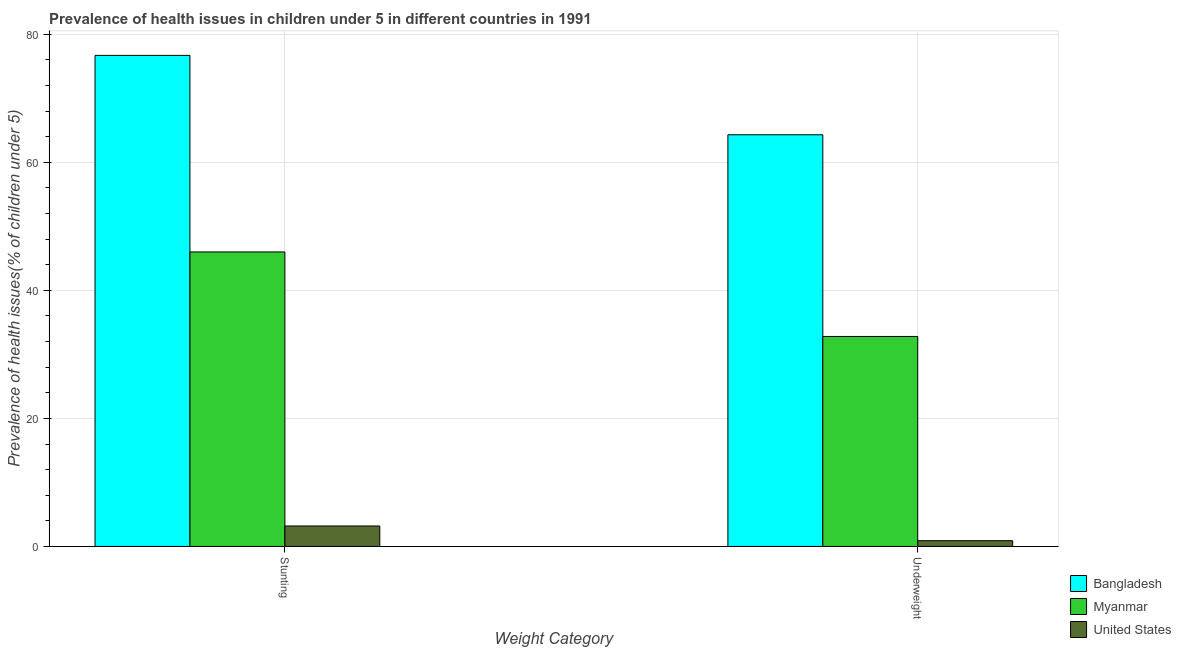How many different coloured bars are there?
Give a very brief answer. 3. How many groups of bars are there?
Ensure brevity in your answer.  2. Are the number of bars per tick equal to the number of legend labels?
Your answer should be very brief. Yes. How many bars are there on the 1st tick from the left?
Offer a terse response. 3. What is the label of the 2nd group of bars from the left?
Provide a succinct answer. Underweight. What is the percentage of underweight children in United States?
Give a very brief answer. 0.9. Across all countries, what is the maximum percentage of underweight children?
Provide a succinct answer. 64.3. Across all countries, what is the minimum percentage of stunted children?
Provide a succinct answer. 3.2. In which country was the percentage of stunted children maximum?
Provide a short and direct response. Bangladesh. What is the total percentage of underweight children in the graph?
Provide a succinct answer. 98. What is the difference between the percentage of stunted children in United States and that in Bangladesh?
Make the answer very short. -73.5. What is the difference between the percentage of stunted children in United States and the percentage of underweight children in Bangladesh?
Keep it short and to the point. -61.1. What is the average percentage of stunted children per country?
Give a very brief answer. 41.97. What is the difference between the percentage of stunted children and percentage of underweight children in Myanmar?
Make the answer very short. 13.2. What is the ratio of the percentage of stunted children in Bangladesh to that in Myanmar?
Offer a terse response. 1.67. Is the percentage of underweight children in Bangladesh less than that in Myanmar?
Provide a succinct answer. No. In how many countries, is the percentage of stunted children greater than the average percentage of stunted children taken over all countries?
Offer a terse response. 2. What does the 3rd bar from the left in Stunting represents?
Your response must be concise. United States. How many bars are there?
Offer a terse response. 6. What is the difference between two consecutive major ticks on the Y-axis?
Your response must be concise. 20. Are the values on the major ticks of Y-axis written in scientific E-notation?
Give a very brief answer. No. Does the graph contain any zero values?
Offer a terse response. No. Does the graph contain grids?
Keep it short and to the point. Yes. What is the title of the graph?
Offer a terse response. Prevalence of health issues in children under 5 in different countries in 1991. What is the label or title of the X-axis?
Provide a succinct answer. Weight Category. What is the label or title of the Y-axis?
Your response must be concise. Prevalence of health issues(% of children under 5). What is the Prevalence of health issues(% of children under 5) in Bangladesh in Stunting?
Your answer should be very brief. 76.7. What is the Prevalence of health issues(% of children under 5) of Myanmar in Stunting?
Ensure brevity in your answer.  46. What is the Prevalence of health issues(% of children under 5) in United States in Stunting?
Offer a terse response. 3.2. What is the Prevalence of health issues(% of children under 5) in Bangladesh in Underweight?
Provide a short and direct response. 64.3. What is the Prevalence of health issues(% of children under 5) of Myanmar in Underweight?
Make the answer very short. 32.8. What is the Prevalence of health issues(% of children under 5) in United States in Underweight?
Give a very brief answer. 0.9. Across all Weight Category, what is the maximum Prevalence of health issues(% of children under 5) of Bangladesh?
Provide a short and direct response. 76.7. Across all Weight Category, what is the maximum Prevalence of health issues(% of children under 5) of Myanmar?
Ensure brevity in your answer.  46. Across all Weight Category, what is the maximum Prevalence of health issues(% of children under 5) in United States?
Make the answer very short. 3.2. Across all Weight Category, what is the minimum Prevalence of health issues(% of children under 5) in Bangladesh?
Offer a terse response. 64.3. Across all Weight Category, what is the minimum Prevalence of health issues(% of children under 5) of Myanmar?
Keep it short and to the point. 32.8. Across all Weight Category, what is the minimum Prevalence of health issues(% of children under 5) of United States?
Provide a short and direct response. 0.9. What is the total Prevalence of health issues(% of children under 5) of Bangladesh in the graph?
Give a very brief answer. 141. What is the total Prevalence of health issues(% of children under 5) in Myanmar in the graph?
Your answer should be very brief. 78.8. What is the total Prevalence of health issues(% of children under 5) in United States in the graph?
Offer a very short reply. 4.1. What is the difference between the Prevalence of health issues(% of children under 5) of Myanmar in Stunting and that in Underweight?
Make the answer very short. 13.2. What is the difference between the Prevalence of health issues(% of children under 5) in United States in Stunting and that in Underweight?
Offer a very short reply. 2.3. What is the difference between the Prevalence of health issues(% of children under 5) in Bangladesh in Stunting and the Prevalence of health issues(% of children under 5) in Myanmar in Underweight?
Offer a terse response. 43.9. What is the difference between the Prevalence of health issues(% of children under 5) of Bangladesh in Stunting and the Prevalence of health issues(% of children under 5) of United States in Underweight?
Make the answer very short. 75.8. What is the difference between the Prevalence of health issues(% of children under 5) in Myanmar in Stunting and the Prevalence of health issues(% of children under 5) in United States in Underweight?
Make the answer very short. 45.1. What is the average Prevalence of health issues(% of children under 5) of Bangladesh per Weight Category?
Keep it short and to the point. 70.5. What is the average Prevalence of health issues(% of children under 5) in Myanmar per Weight Category?
Provide a succinct answer. 39.4. What is the average Prevalence of health issues(% of children under 5) in United States per Weight Category?
Make the answer very short. 2.05. What is the difference between the Prevalence of health issues(% of children under 5) in Bangladesh and Prevalence of health issues(% of children under 5) in Myanmar in Stunting?
Make the answer very short. 30.7. What is the difference between the Prevalence of health issues(% of children under 5) in Bangladesh and Prevalence of health issues(% of children under 5) in United States in Stunting?
Make the answer very short. 73.5. What is the difference between the Prevalence of health issues(% of children under 5) in Myanmar and Prevalence of health issues(% of children under 5) in United States in Stunting?
Make the answer very short. 42.8. What is the difference between the Prevalence of health issues(% of children under 5) in Bangladesh and Prevalence of health issues(% of children under 5) in Myanmar in Underweight?
Make the answer very short. 31.5. What is the difference between the Prevalence of health issues(% of children under 5) of Bangladesh and Prevalence of health issues(% of children under 5) of United States in Underweight?
Keep it short and to the point. 63.4. What is the difference between the Prevalence of health issues(% of children under 5) in Myanmar and Prevalence of health issues(% of children under 5) in United States in Underweight?
Offer a terse response. 31.9. What is the ratio of the Prevalence of health issues(% of children under 5) of Bangladesh in Stunting to that in Underweight?
Provide a short and direct response. 1.19. What is the ratio of the Prevalence of health issues(% of children under 5) in Myanmar in Stunting to that in Underweight?
Your answer should be very brief. 1.4. What is the ratio of the Prevalence of health issues(% of children under 5) of United States in Stunting to that in Underweight?
Keep it short and to the point. 3.56. What is the difference between the highest and the second highest Prevalence of health issues(% of children under 5) of Bangladesh?
Provide a short and direct response. 12.4. 